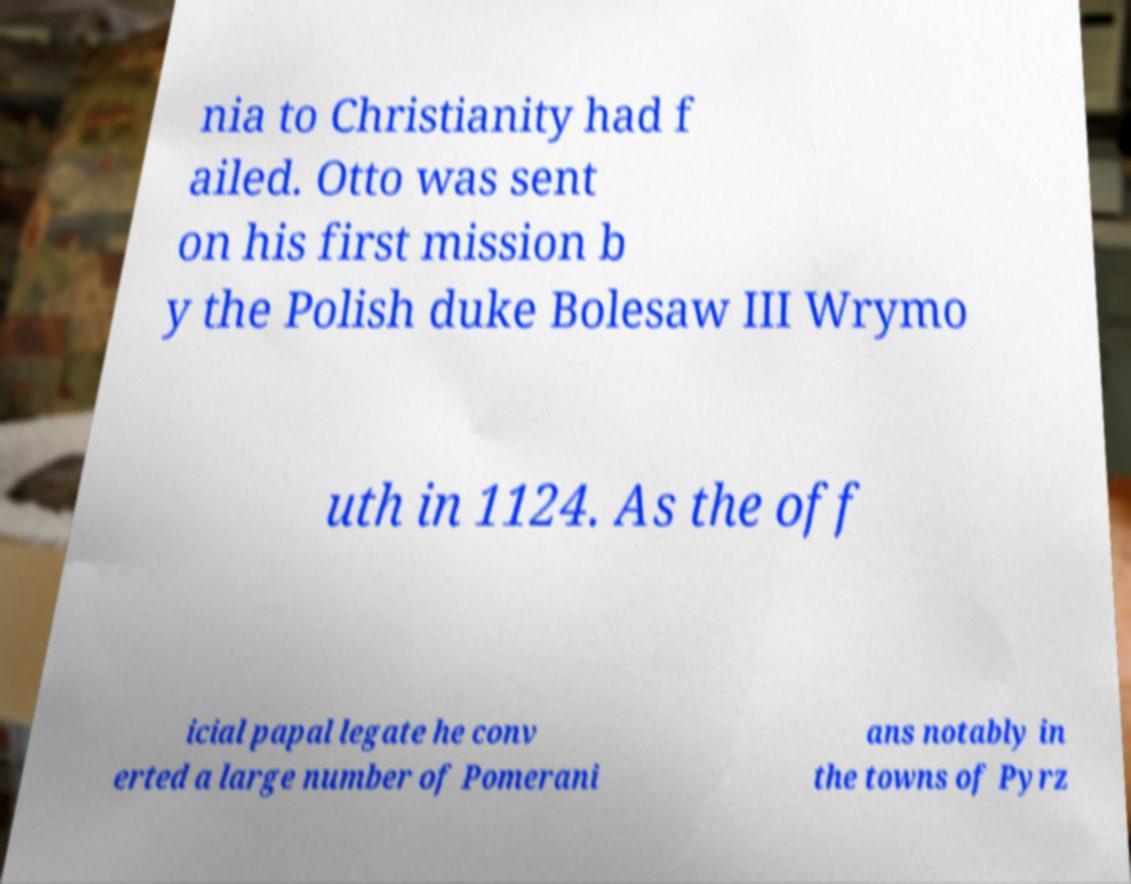Please identify and transcribe the text found in this image. nia to Christianity had f ailed. Otto was sent on his first mission b y the Polish duke Bolesaw III Wrymo uth in 1124. As the off icial papal legate he conv erted a large number of Pomerani ans notably in the towns of Pyrz 